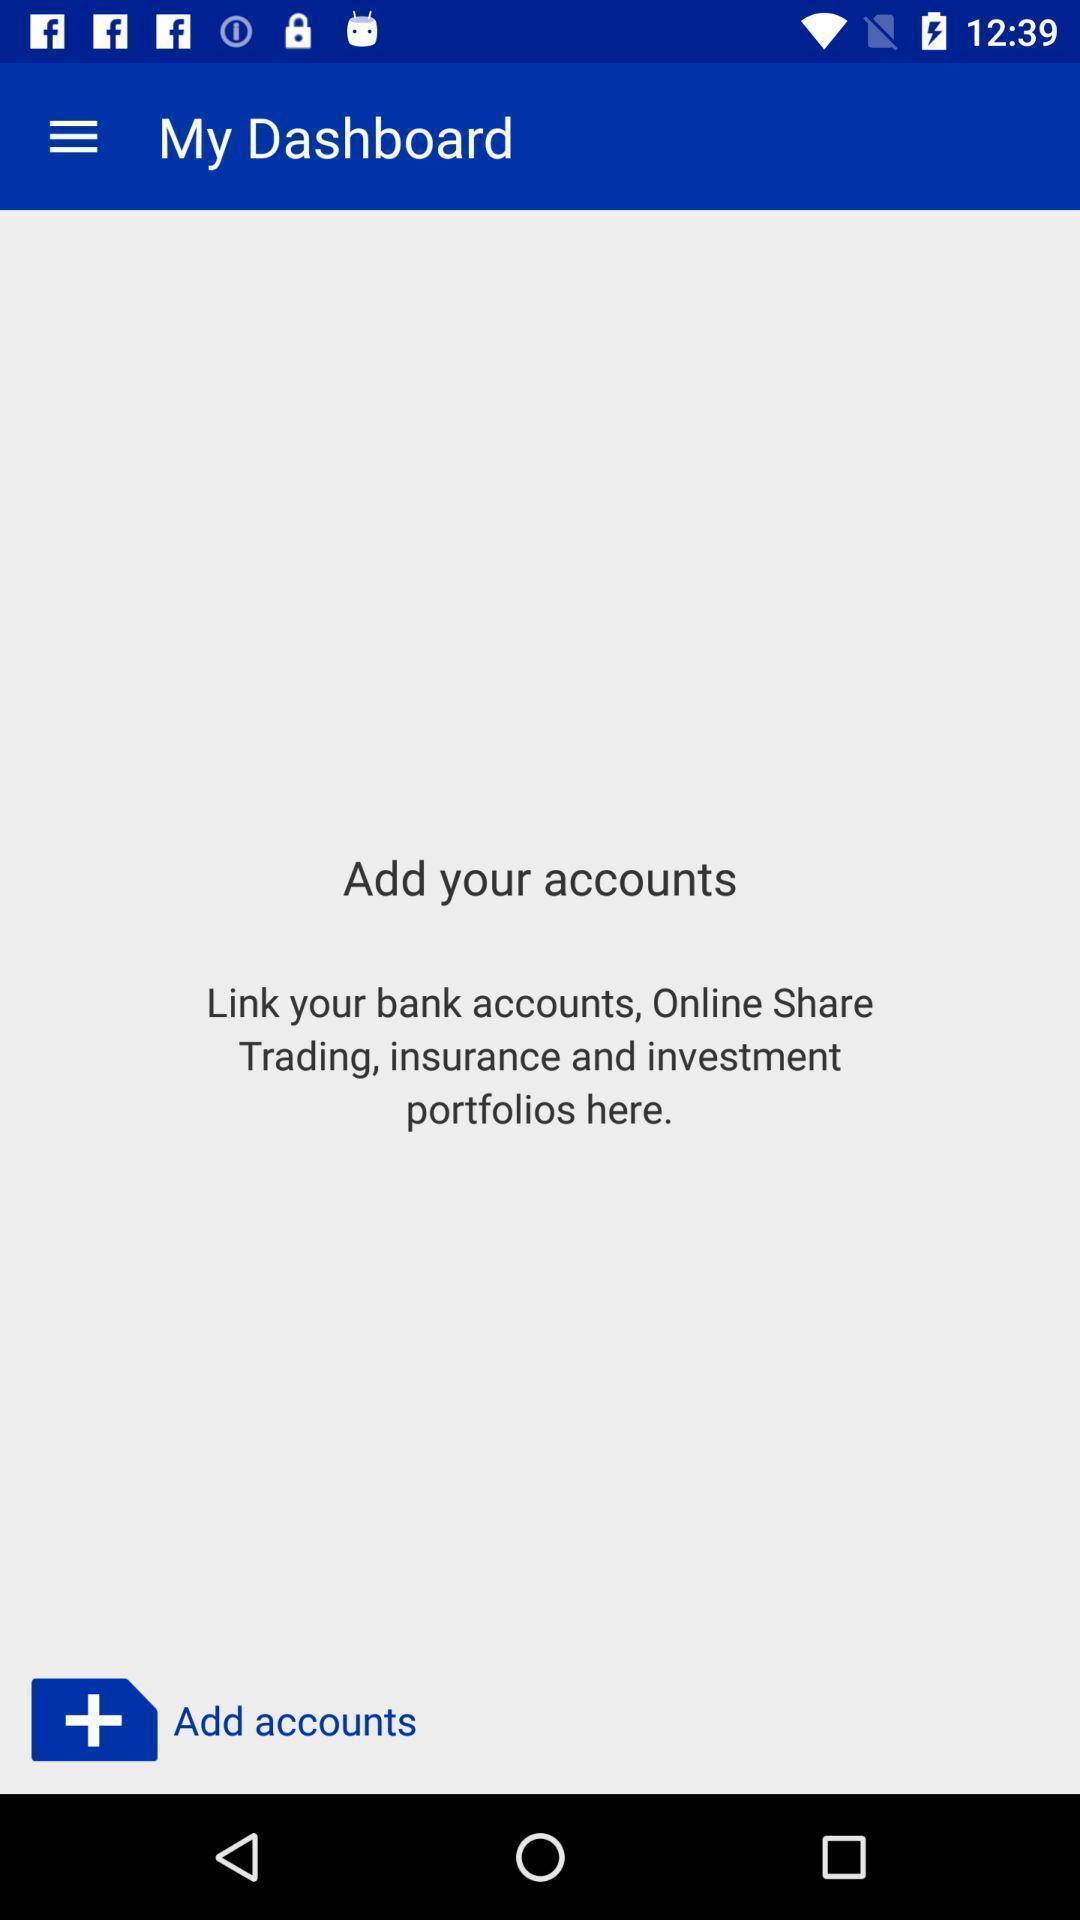Explain what's happening in this screen capture. Screen displaying the blank page in my dashboard tab. 